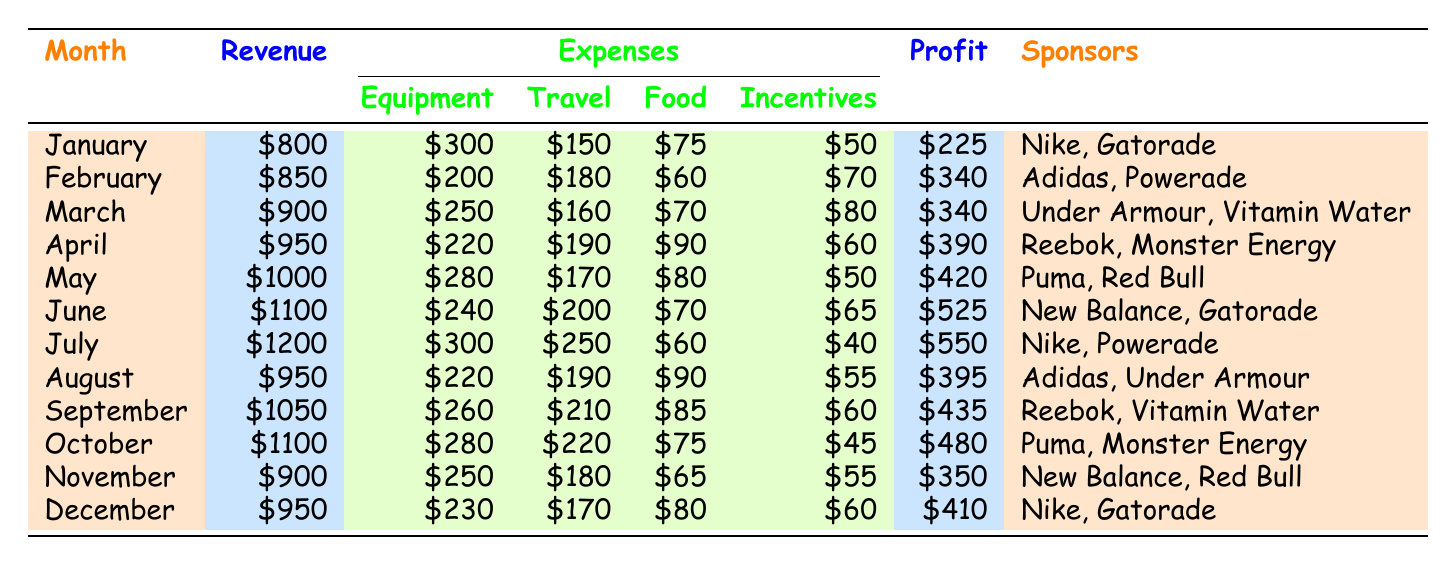What was the highest revenue month? Looking at the "Revenue" column, June has the highest value with $1100. No other month exceeds this amount.
Answer: June What were the total expenses in March? To find the total expenses in March, add each expense category: Equipment ($250) + Travel ($160) + Food ($70) + Sponsored Post Incentives ($80) = $560.
Answer: $560 Was the profit for November greater than that for January? The profit for November is $350 while the profit for January is $225. Since $350 is greater than $225, the statement is true.
Answer: Yes What are the average travel expenses for the year? First, sum the travel expenses for each month: 150 + 180 + 160 + 190 + 170 + 200 + 250 + 190 + 210 + 220 + 180 + 170 = 2,270. Then divide that sum by the number of months (12) to get the average, which is 2,270 / 12 = 189.17, or approximately $189.
Answer: $189 Did April have lower revenue than July? The revenue for April is $950, while for July it is $1200. Therefore, April's revenue is lower than July's.
Answer: Yes What was the total profit for the months of June, July, and August combined? First, find the individual profits for these months: June ($525), July ($550), and August ($395). Adding these gives $525 + $550 + $395 = $1470.
Answer: $1470 Which month had the lowest food expenses, and what was the amount? Reviewing the food expense for each month, the lowest amount is $60, which occurred in both July and the Jan trough March months. However, since July is the latest month, it can be indicated as the last time food expenses were at their lowest.
Answer: July, $60 How much did the total sponsored post incentives amount to in the first quarter? The sponsored post incentives for January ($50), February ($70), and March ($80) need to be added: $50 + $70 + $80 = $200 for the total amount in the first quarter.
Answer: $200 